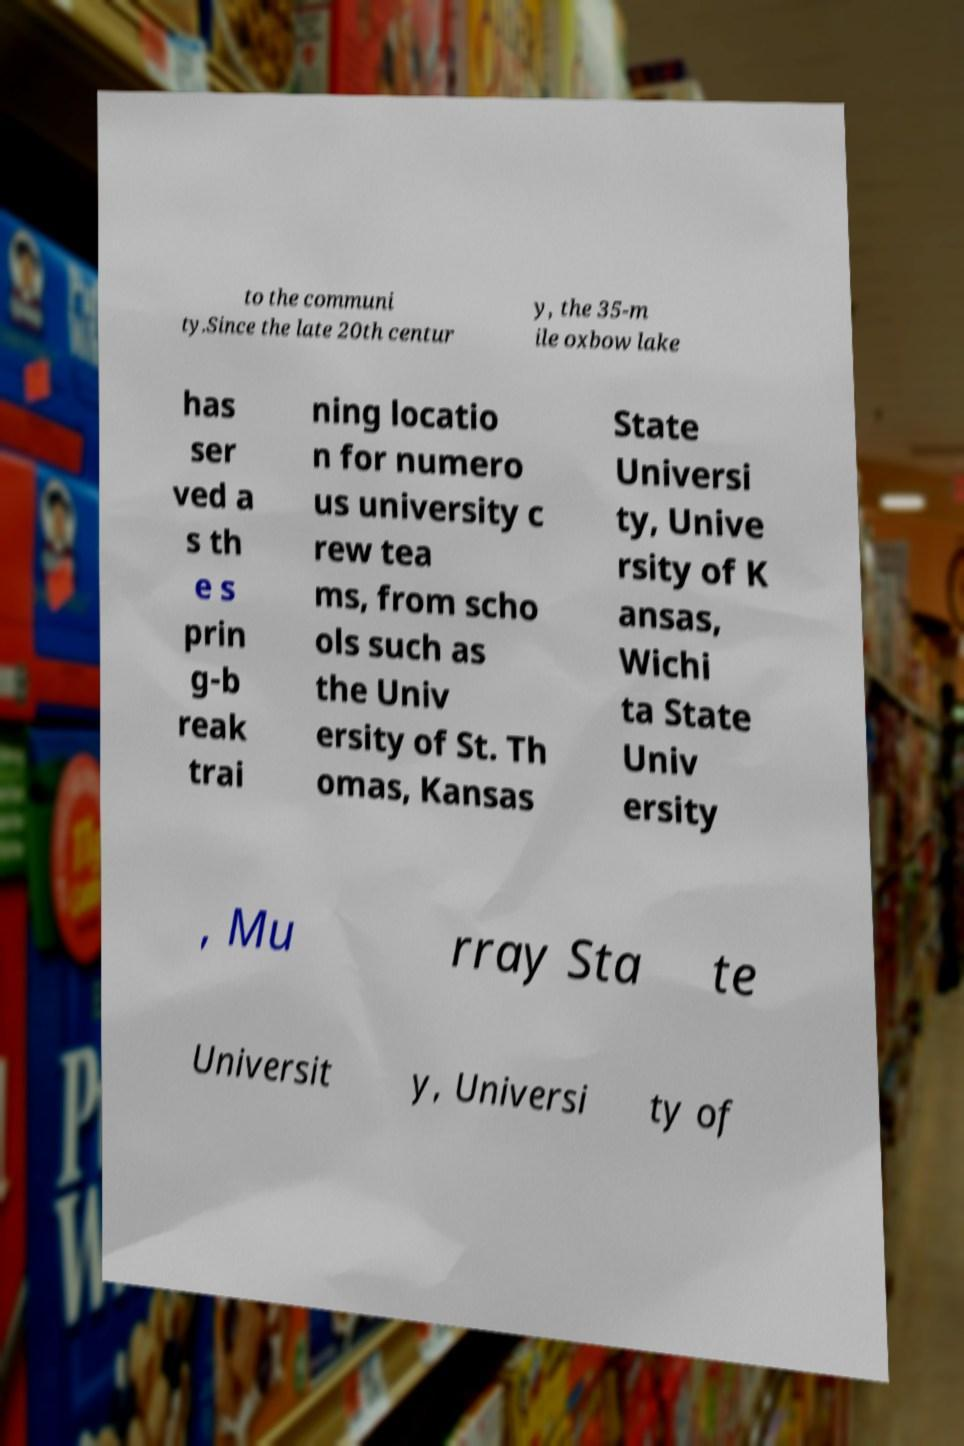Can you read and provide the text displayed in the image?This photo seems to have some interesting text. Can you extract and type it out for me? to the communi ty.Since the late 20th centur y, the 35-m ile oxbow lake has ser ved a s th e s prin g-b reak trai ning locatio n for numero us university c rew tea ms, from scho ols such as the Univ ersity of St. Th omas, Kansas State Universi ty, Unive rsity of K ansas, Wichi ta State Univ ersity , Mu rray Sta te Universit y, Universi ty of 